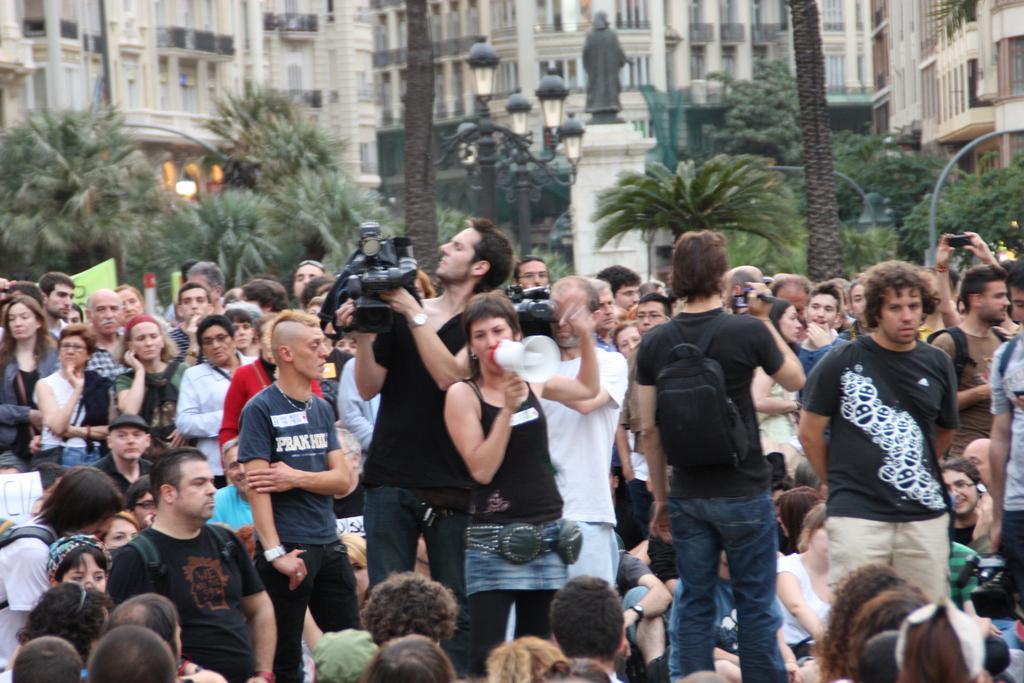Please provide a concise description of this image. In this image I can see people among them some are standing and some are sitting. I can also see some are holding some objects in hand. In the background I can see trees, buildings and street lights. 